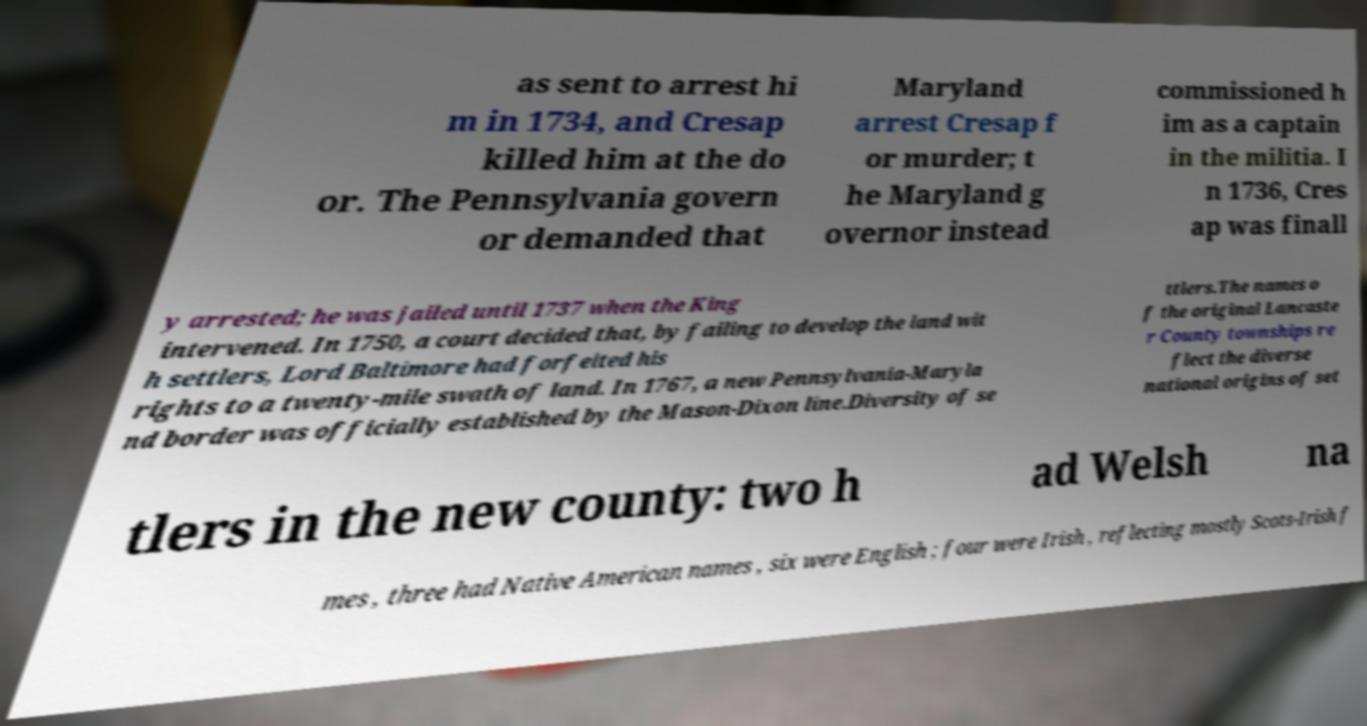For documentation purposes, I need the text within this image transcribed. Could you provide that? as sent to arrest hi m in 1734, and Cresap killed him at the do or. The Pennsylvania govern or demanded that Maryland arrest Cresap f or murder; t he Maryland g overnor instead commissioned h im as a captain in the militia. I n 1736, Cres ap was finall y arrested; he was jailed until 1737 when the King intervened. In 1750, a court decided that, by failing to develop the land wit h settlers, Lord Baltimore had forfeited his rights to a twenty-mile swath of land. In 1767, a new Pennsylvania-Maryla nd border was officially established by the Mason-Dixon line.Diversity of se ttlers.The names o f the original Lancaste r County townships re flect the diverse national origins of set tlers in the new county: two h ad Welsh na mes , three had Native American names , six were English ; four were Irish , reflecting mostly Scots-Irish f 